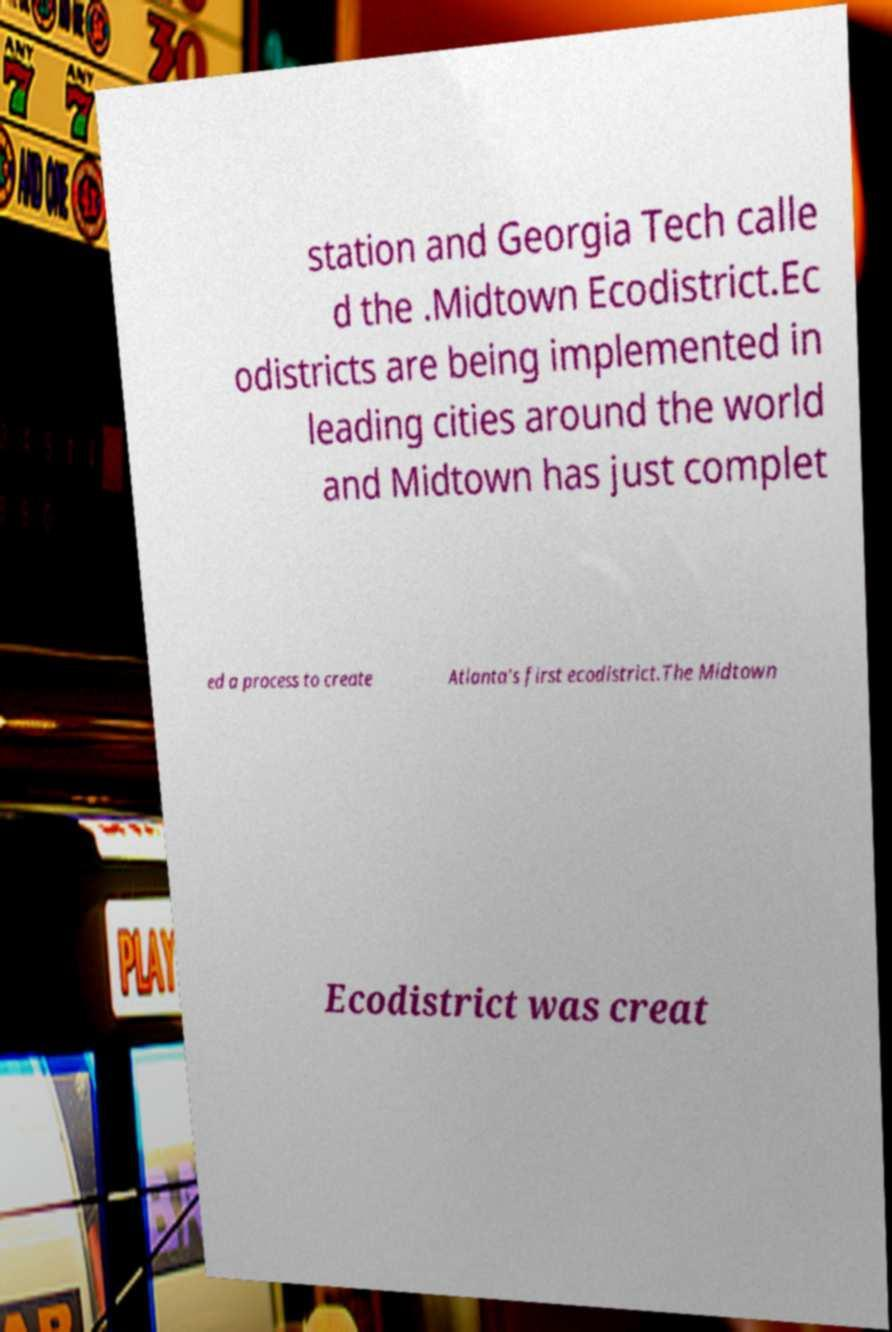Can you read and provide the text displayed in the image?This photo seems to have some interesting text. Can you extract and type it out for me? station and Georgia Tech calle d the .Midtown Ecodistrict.Ec odistricts are being implemented in leading cities around the world and Midtown has just complet ed a process to create Atlanta's first ecodistrict.The Midtown Ecodistrict was creat 